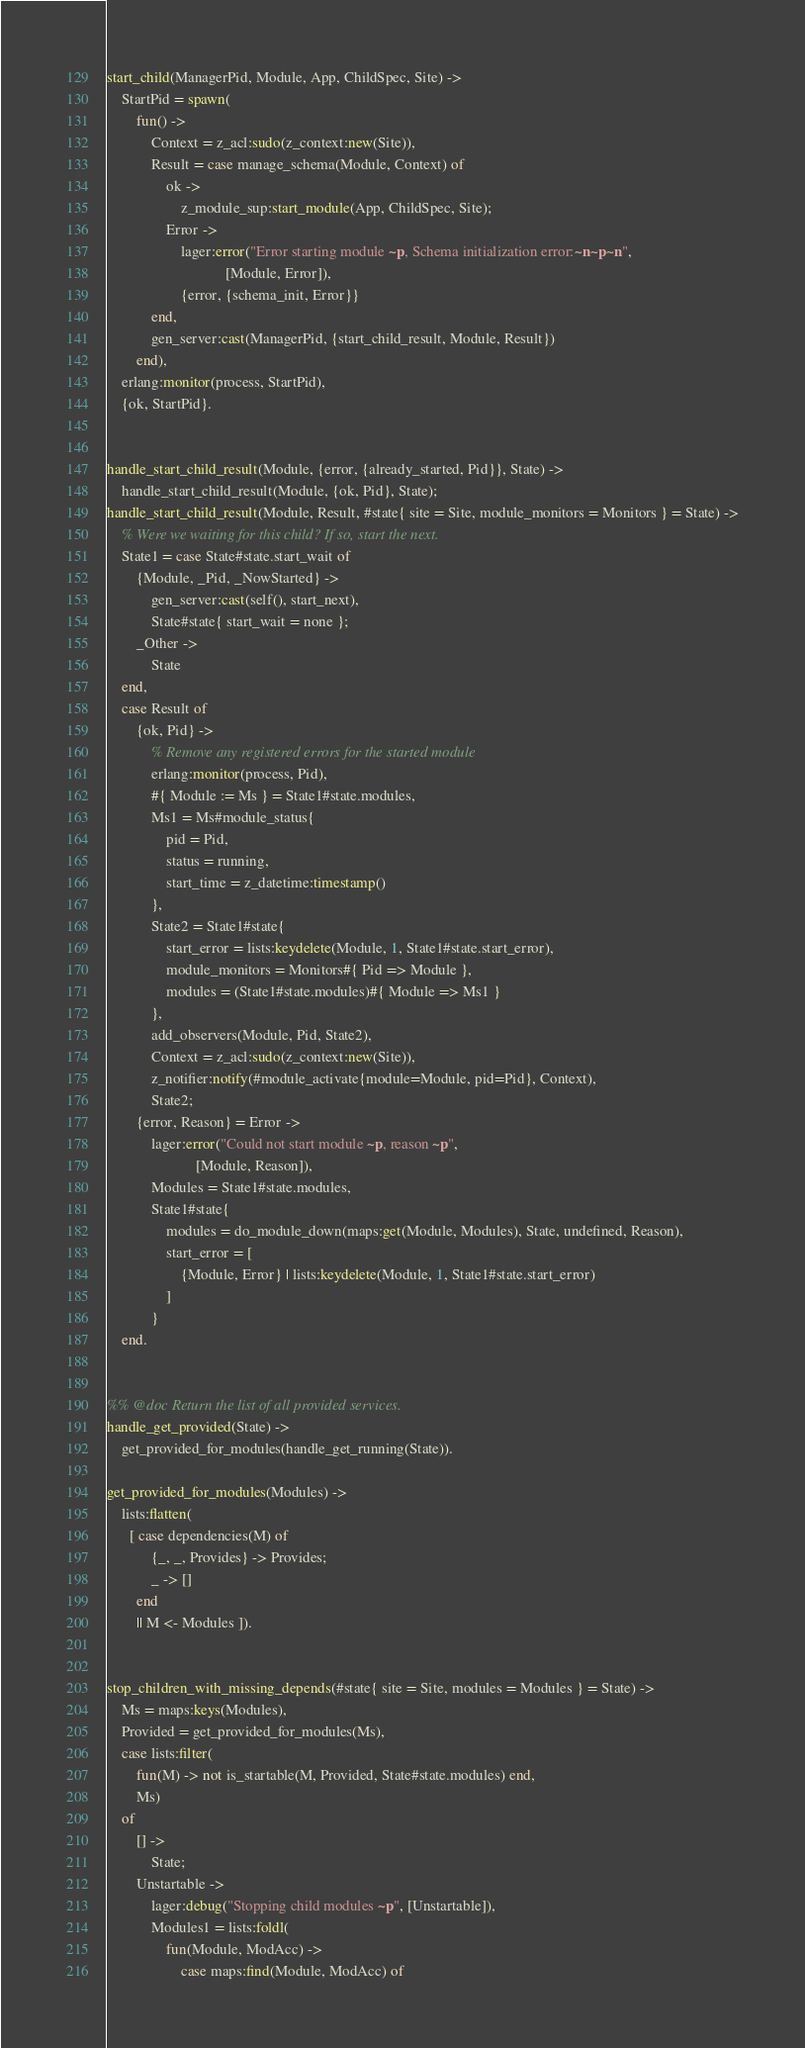<code> <loc_0><loc_0><loc_500><loc_500><_Erlang_>start_child(ManagerPid, Module, App, ChildSpec, Site) ->
    StartPid = spawn(
        fun() ->
            Context = z_acl:sudo(z_context:new(Site)),
            Result = case manage_schema(Module, Context) of
                ok ->
                    z_module_sup:start_module(App, ChildSpec, Site);
                Error ->
                    lager:error("Error starting module ~p, Schema initialization error:~n~p~n",
                                [Module, Error]),
                    {error, {schema_init, Error}}
            end,
            gen_server:cast(ManagerPid, {start_child_result, Module, Result})
        end),
    erlang:monitor(process, StartPid),
    {ok, StartPid}.


handle_start_child_result(Module, {error, {already_started, Pid}}, State) ->
    handle_start_child_result(Module, {ok, Pid}, State);
handle_start_child_result(Module, Result, #state{ site = Site, module_monitors = Monitors } = State) ->
    % Were we waiting for this child? If so, start the next.
    State1 = case State#state.start_wait of
        {Module, _Pid, _NowStarted} ->
            gen_server:cast(self(), start_next),
            State#state{ start_wait = none };
        _Other ->
            State
    end,
    case Result of
        {ok, Pid} ->
            % Remove any registered errors for the started module
            erlang:monitor(process, Pid),
            #{ Module := Ms } = State1#state.modules,
            Ms1 = Ms#module_status{
                pid = Pid,
                status = running,
                start_time = z_datetime:timestamp()
            },
            State2 = State1#state{
                start_error = lists:keydelete(Module, 1, State1#state.start_error),
                module_monitors = Monitors#{ Pid => Module },
                modules = (State1#state.modules)#{ Module => Ms1 }
            },
            add_observers(Module, Pid, State2),
            Context = z_acl:sudo(z_context:new(Site)),
            z_notifier:notify(#module_activate{module=Module, pid=Pid}, Context),
            State2;
        {error, Reason} = Error ->
            lager:error("Could not start module ~p, reason ~p",
                        [Module, Reason]),
            Modules = State1#state.modules,
            State1#state{
                modules = do_module_down(maps:get(Module, Modules), State, undefined, Reason),
                start_error = [
                    {Module, Error} | lists:keydelete(Module, 1, State1#state.start_error)
                ]
            }
    end.


%% @doc Return the list of all provided services.
handle_get_provided(State) ->
    get_provided_for_modules(handle_get_running(State)).

get_provided_for_modules(Modules) ->
    lists:flatten(
      [ case dependencies(M) of
            {_, _, Provides} -> Provides;
            _ -> []
        end
        || M <- Modules ]).


stop_children_with_missing_depends(#state{ site = Site, modules = Modules } = State) ->
    Ms = maps:keys(Modules),
    Provided = get_provided_for_modules(Ms),
    case lists:filter(
        fun(M) -> not is_startable(M, Provided, State#state.modules) end,
        Ms)
    of
        [] ->
            State;
        Unstartable ->
            lager:debug("Stopping child modules ~p", [Unstartable]),
            Modules1 = lists:foldl(
                fun(Module, ModAcc) ->
                    case maps:find(Module, ModAcc) of</code> 